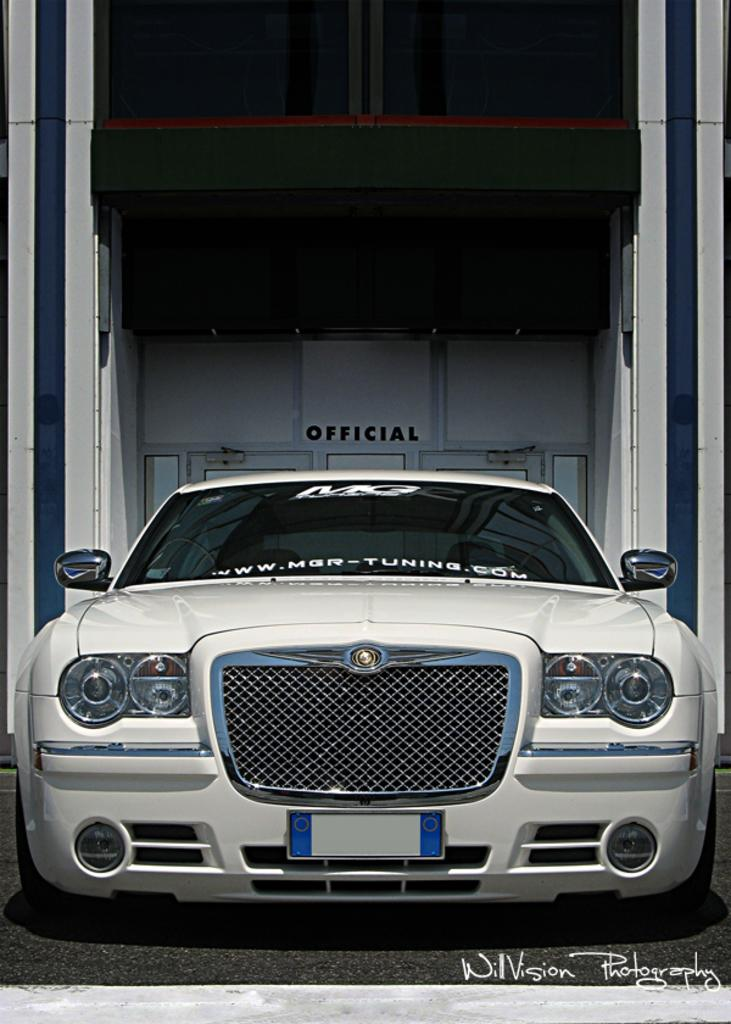What type of vehicle is in the image? There is a white car in the image. What is located to the left of the car? There is a wall to the left of the car. What is at the bottom of the image? There is a road at the bottom of the image. What architectural features can be seen in the background of the image? There are doors and windows visible in the background of the image. Can you see a thumbprint on the car's windshield in the image? There is no thumbprint visible on the car's windshield in the image. Are there any snakes slithering on the road in the image? There are no snakes present in the image; it only features a white car, a wall, a road, and architectural features in the background. 